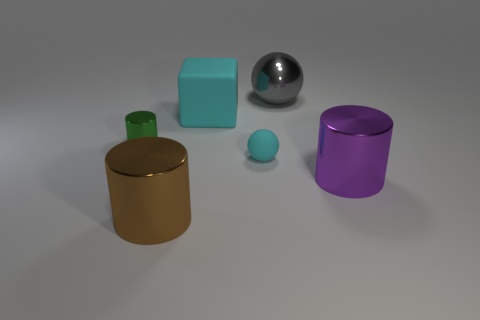Is the number of cyan balls that are behind the big gray metal sphere greater than the number of things right of the tiny cyan sphere?
Your response must be concise. No. What size is the sphere that is the same color as the large rubber thing?
Offer a very short reply. Small. The large ball has what color?
Your answer should be very brief. Gray. What is the color of the shiny thing that is both left of the shiny sphere and behind the matte ball?
Ensure brevity in your answer.  Green. There is a big shiny object that is behind the cyan matte object behind the small object on the left side of the cyan rubber cube; what color is it?
Keep it short and to the point. Gray. The block that is the same size as the gray metal sphere is what color?
Offer a very short reply. Cyan. There is a small object that is right of the large thing to the left of the cyan thing behind the small cyan ball; what is its shape?
Offer a terse response. Sphere. What is the shape of the rubber thing that is the same color as the small ball?
Make the answer very short. Cube. What number of things are either red rubber cylinders or big cylinders that are left of the gray object?
Give a very brief answer. 1. There is a thing on the right side of the gray sphere; is its size the same as the large cyan matte cube?
Ensure brevity in your answer.  Yes. 